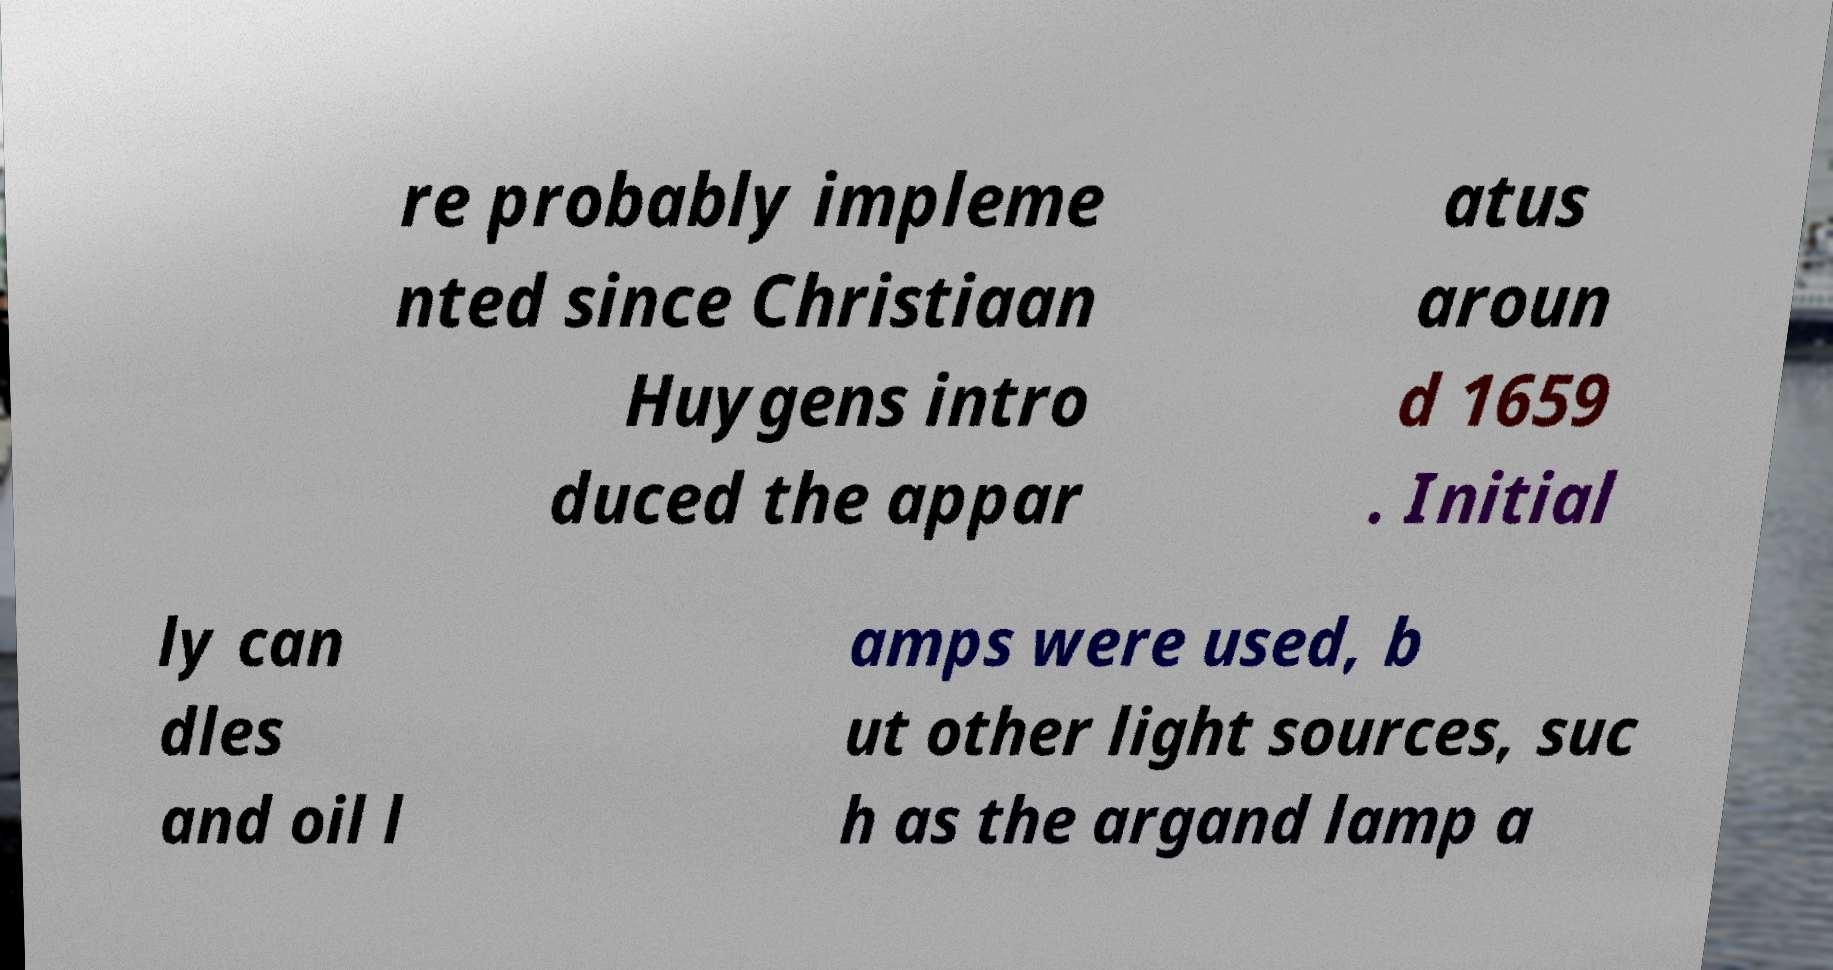Please identify and transcribe the text found in this image. re probably impleme nted since Christiaan Huygens intro duced the appar atus aroun d 1659 . Initial ly can dles and oil l amps were used, b ut other light sources, suc h as the argand lamp a 